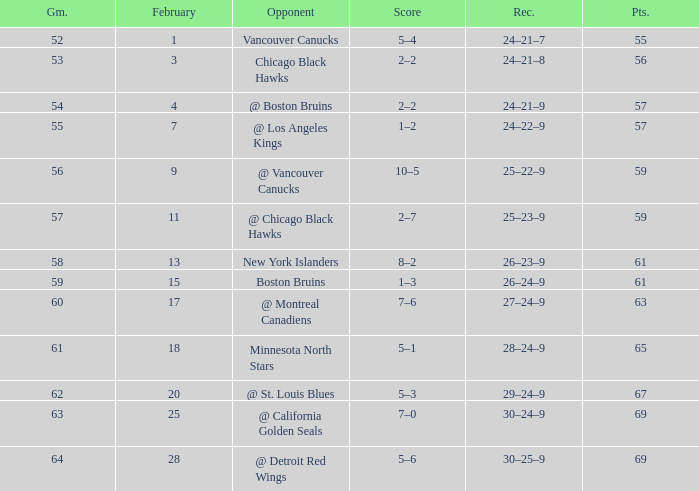How many february games had a record of 29–24–9? 20.0. 